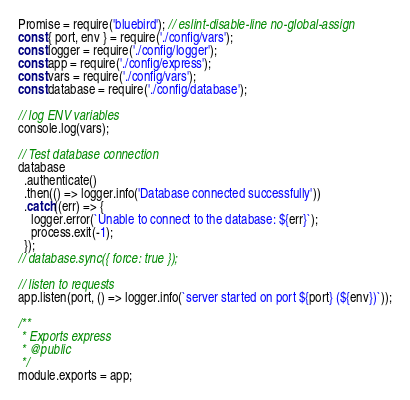Convert code to text. <code><loc_0><loc_0><loc_500><loc_500><_JavaScript_>Promise = require('bluebird'); // eslint-disable-line no-global-assign
const { port, env } = require('./config/vars');
const logger = require('./config/logger');
const app = require('./config/express');
const vars = require('./config/vars');
const database = require('./config/database');

// log ENV variables
console.log(vars);

// Test database connection
database
  .authenticate()
  .then(() => logger.info('Database connected successfully'))
  .catch((err) => {
    logger.error(`Unable to connect to the database: ${err}`);
    process.exit(-1);
  });
// database.sync({ force: true });

// listen to requests
app.listen(port, () => logger.info(`server started on port ${port} (${env})`));

/**
 * Exports express
 * @public
 */
module.exports = app;
</code> 